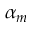<formula> <loc_0><loc_0><loc_500><loc_500>\alpha _ { m }</formula> 